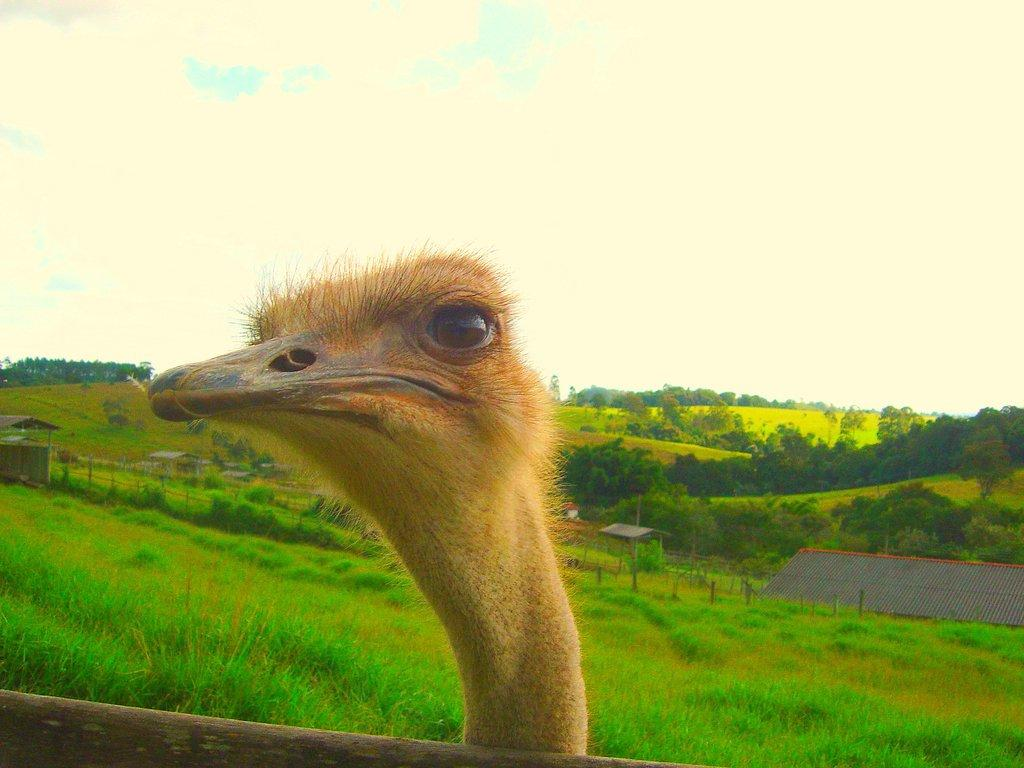What type of animal is in the image? There is an ostrich in the image. What can be seen in the background of the image? There are trees in the image. What is visible above the trees in the image? The sky is visible in the image. What type of class is being taught in the image? There is no class or teaching activity present in the image; it features an ostrich, trees, and the sky. How many times does the ostrich sneeze in the image? The ostrich does not sneeze in the image; it is a still image of the animal. 